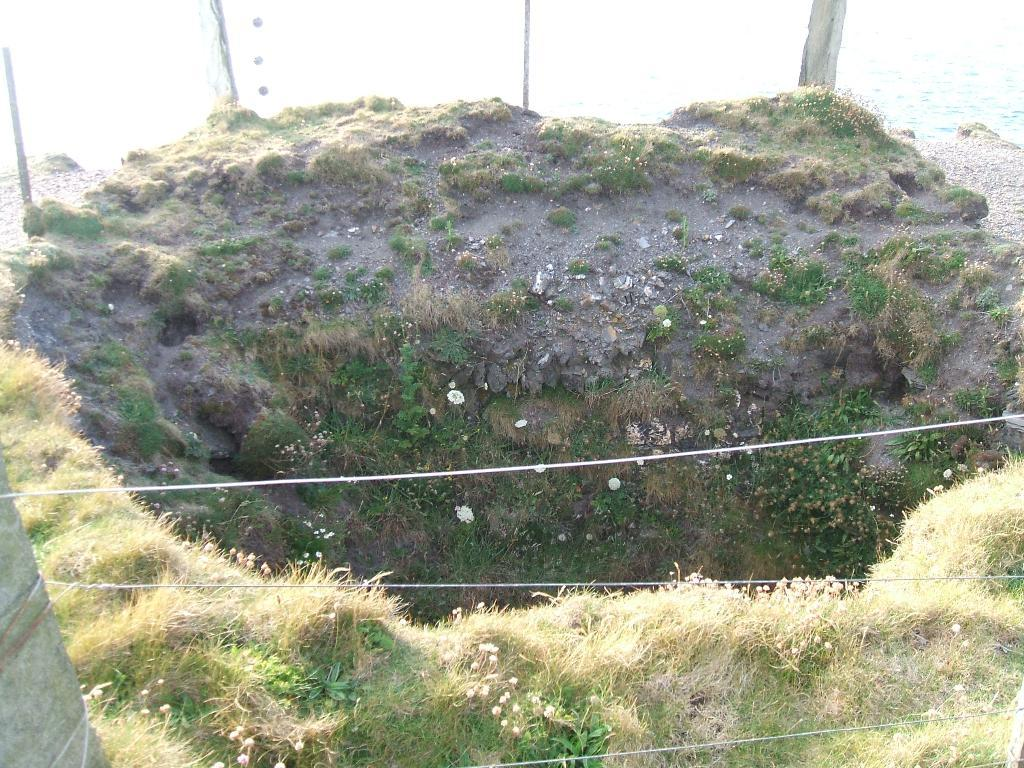What type of ground is visible in the image? The ground in the image is covered with grass and low vegetation. What can be seen behind the grass and low vegetation? There is water visible behind the grass and low vegetation. How many geese are seen eating lunch on the grass in the image? There are no geese or any indication of lunch in the image. 